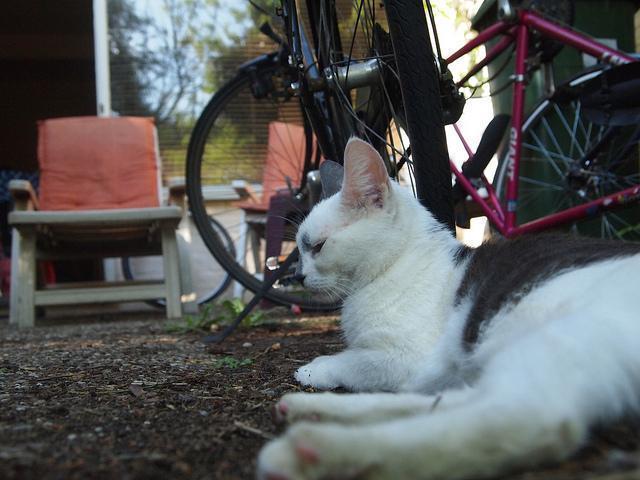What faces the most danger of getting hurt if people go to ride the bikes?
Make your selection from the four choices given to correctly answer the question.
Options: Cat, people, chair, bikes. Cat. 